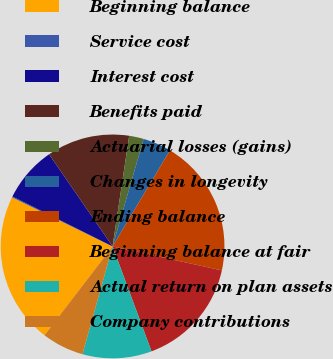<chart> <loc_0><loc_0><loc_500><loc_500><pie_chart><fcel>Beginning balance<fcel>Service cost<fcel>Interest cost<fcel>Benefits paid<fcel>Actuarial losses (gains)<fcel>Changes in longevity<fcel>Ending balance<fcel>Beginning balance at fair<fcel>Actual return on plan assets<fcel>Company contributions<nl><fcel>21.83%<fcel>0.14%<fcel>8.03%<fcel>11.97%<fcel>2.11%<fcel>4.09%<fcel>19.86%<fcel>15.91%<fcel>10.0%<fcel>6.06%<nl></chart> 